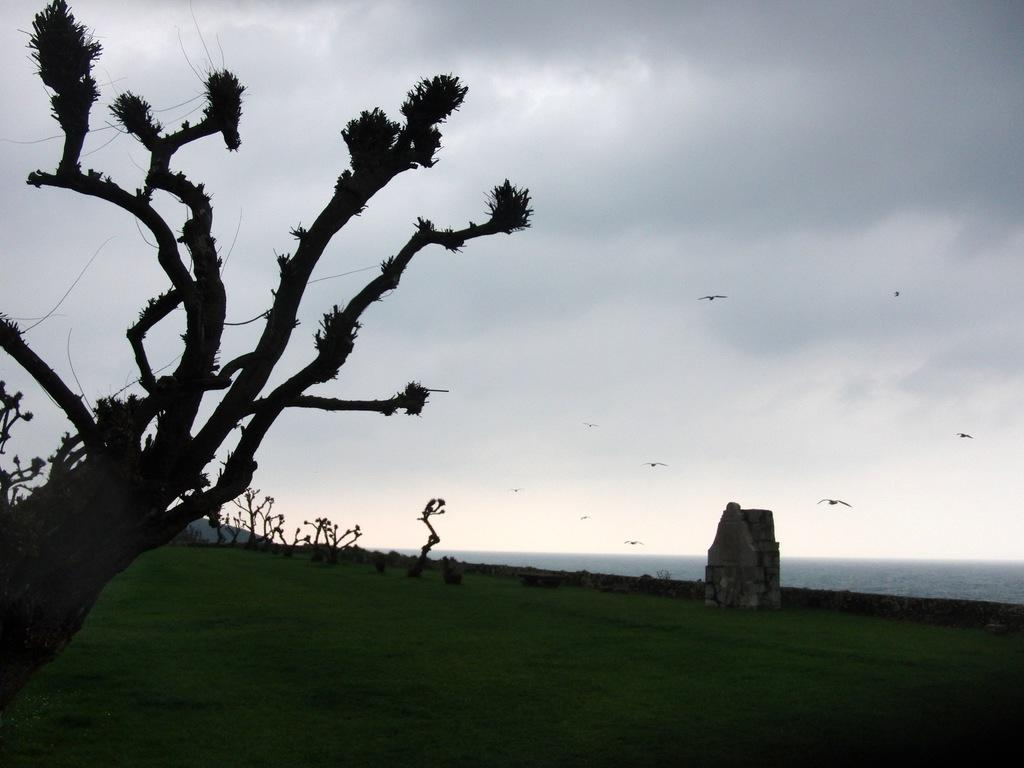What is the main subject in the foreground of the image? There is a tree in the foreground of the image. What type of vegetation surrounds the tree in the foreground? There is a lot of grass around the tree. What can be seen in the background of the image? There are trees in the background of the image. Are there any other objects or features in the background? Yes, there is a stone beside the trees in the background. What type of bag is hanging from the tree in the image? There is no bag hanging from the tree in the image; it only features a tree, grass, and trees in the background with a stone. 